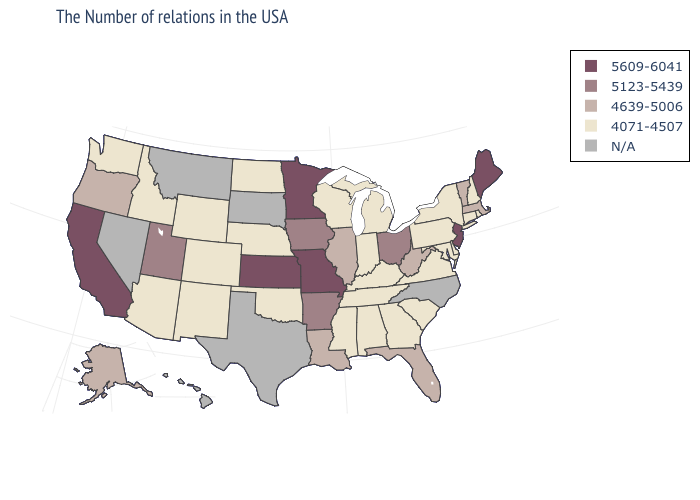Name the states that have a value in the range 4639-5006?
Give a very brief answer. Massachusetts, Vermont, West Virginia, Florida, Illinois, Louisiana, Oregon, Alaska. What is the value of Wyoming?
Write a very short answer. 4071-4507. Name the states that have a value in the range 5123-5439?
Short answer required. Ohio, Arkansas, Iowa, Utah. Does the map have missing data?
Write a very short answer. Yes. Does Rhode Island have the lowest value in the Northeast?
Be succinct. Yes. What is the value of Nevada?
Keep it brief. N/A. Name the states that have a value in the range 4639-5006?
Concise answer only. Massachusetts, Vermont, West Virginia, Florida, Illinois, Louisiana, Oregon, Alaska. What is the highest value in states that border Idaho?
Be succinct. 5123-5439. What is the lowest value in states that border Iowa?
Give a very brief answer. 4071-4507. Name the states that have a value in the range 5609-6041?
Write a very short answer. Maine, New Jersey, Missouri, Minnesota, Kansas, California. What is the lowest value in the MidWest?
Give a very brief answer. 4071-4507. What is the highest value in the MidWest ?
Answer briefly. 5609-6041. 